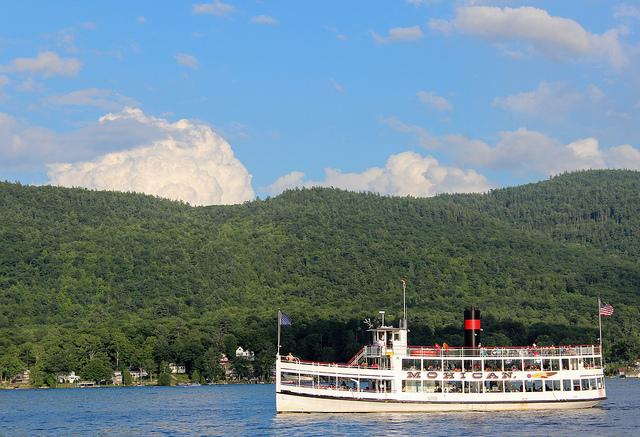Who is on the boat? passengers 